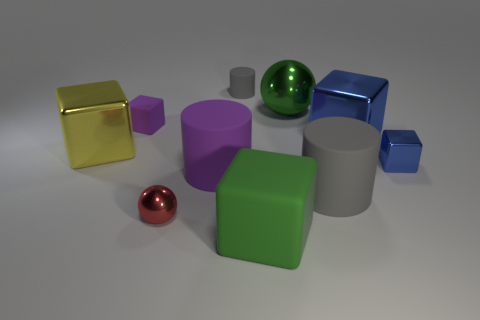Subtract all blue blocks. How many were subtracted if there are1blue blocks left? 1 Subtract all big blue metallic blocks. How many blocks are left? 4 Subtract all red blocks. How many gray cylinders are left? 2 Subtract 1 blocks. How many blocks are left? 4 Subtract all blue cubes. How many cubes are left? 3 Add 9 big green metal things. How many big green metal things exist? 10 Subtract 1 yellow blocks. How many objects are left? 9 Subtract all balls. How many objects are left? 8 Subtract all cyan cylinders. Subtract all green cubes. How many cylinders are left? 3 Subtract all red things. Subtract all big rubber things. How many objects are left? 6 